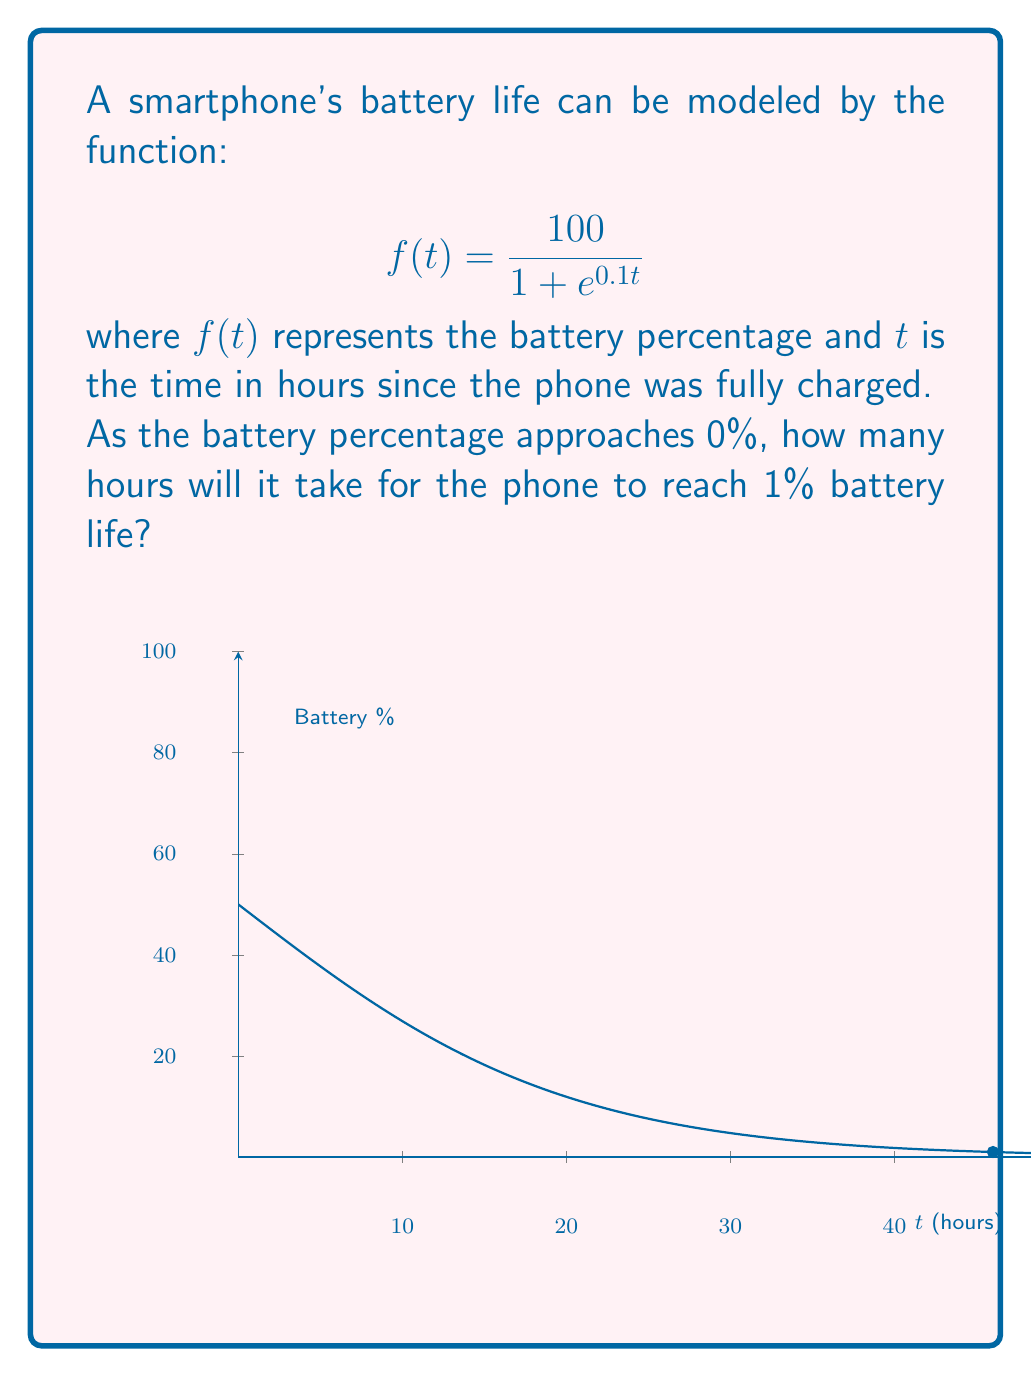Help me with this question. Let's approach this step-by-step:

1) We want to find the time $t$ when the battery percentage $f(t)$ is 1%. So, we need to solve the equation:

   $$\frac{100}{1 + e^{0.1t}} = 1$$

2) Let's solve this equation:
   
   $$100 = 1 + e^{0.1t}$$
   $$99 = e^{0.1t}$$

3) Take the natural logarithm of both sides:
   
   $$\ln(99) = 0.1t$$

4) Solve for $t$:
   
   $$t = \frac{\ln(99)}{0.1}$$

5) Use a calculator to compute this value:
   
   $$t \approx 46.05$$

6) Therefore, it will take approximately 46.05 hours for the battery to reach 1%.

This model demonstrates how the battery life approaches 0% asymptotically, meaning it gets very close to 0% but never actually reaches it in finite time.
Answer: $46.05$ hours 